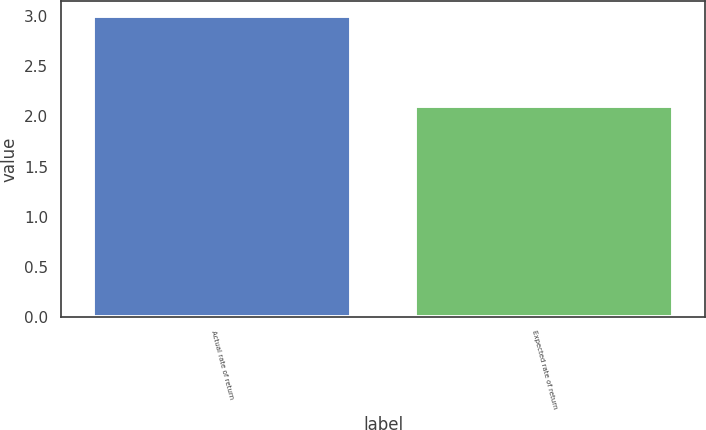Convert chart. <chart><loc_0><loc_0><loc_500><loc_500><bar_chart><fcel>Actual rate of return<fcel>Expected rate of return<nl><fcel>3<fcel>2.1<nl></chart> 